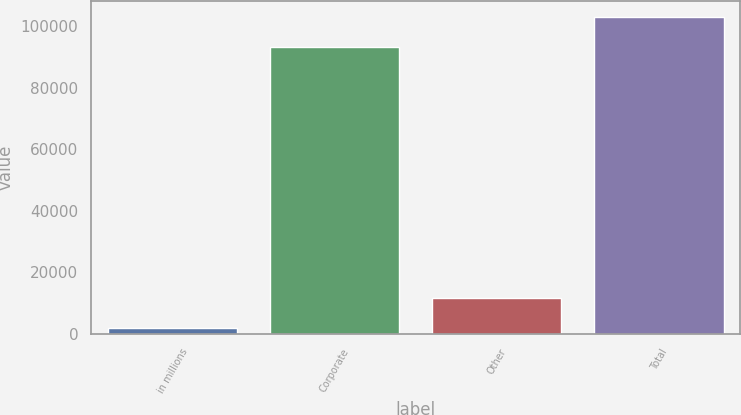<chart> <loc_0><loc_0><loc_500><loc_500><bar_chart><fcel>in millions<fcel>Corporate<fcel>Other<fcel>Total<nl><fcel>2016<fcel>93407<fcel>11618.9<fcel>103010<nl></chart> 